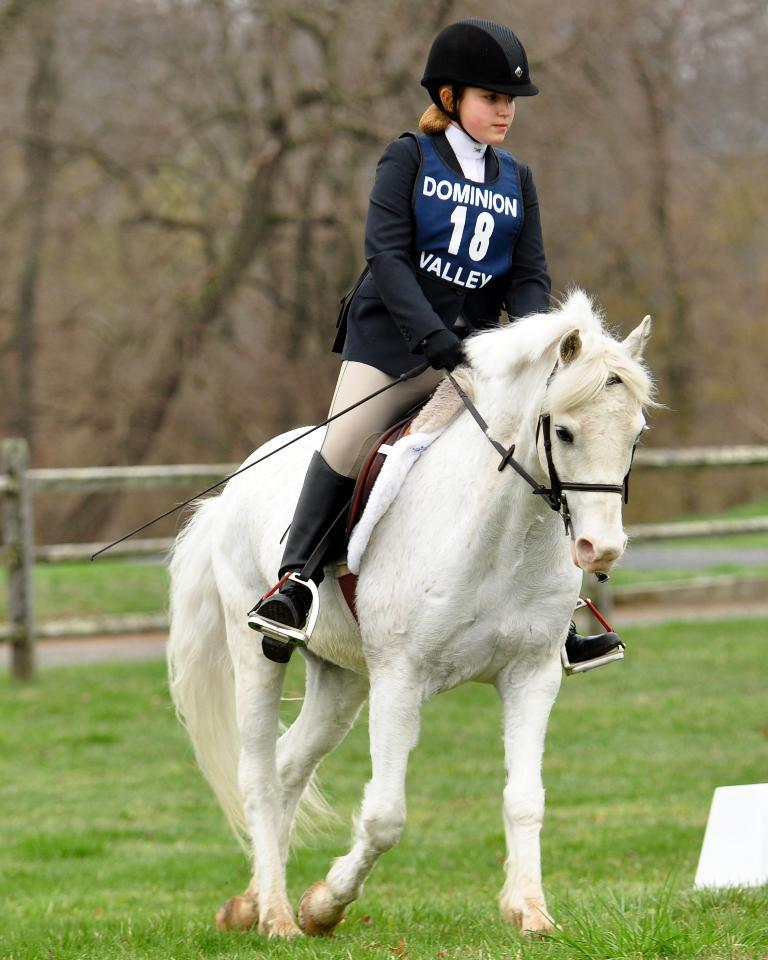Who is the main subject in the image? There is a woman in the image. What is the woman doing in the image? The woman is sitting on a horse. What type of terrain is visible in the image? The land is covered with grass. Can you describe the background of the image? The background is blurred, and there are trees and a fence visible. What type of fuel does the woman use to power the horse in the image? The image does not show any fuel being used to power the horse, as horses are living creatures and do not require fuel to function. 